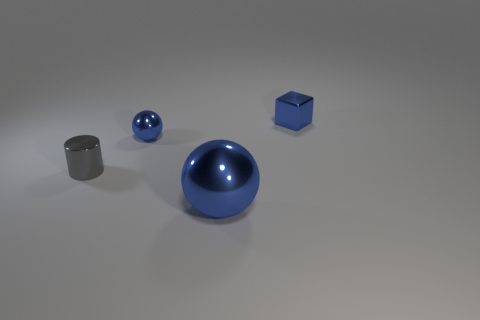What could be the purpose of these objects in this arrangement? This arrangement of objects might be designed for a demonstration or educational purpose, such as to illustrate principles of geometry, light reflection, or material properties in a controlled environment. Could these objects have any practical use? While they resemble common objects like a bowl or a box, their pristine condition and context suggest they are more likely to be models or props used for visual effects, design visualization, or as 3D modeling references. 